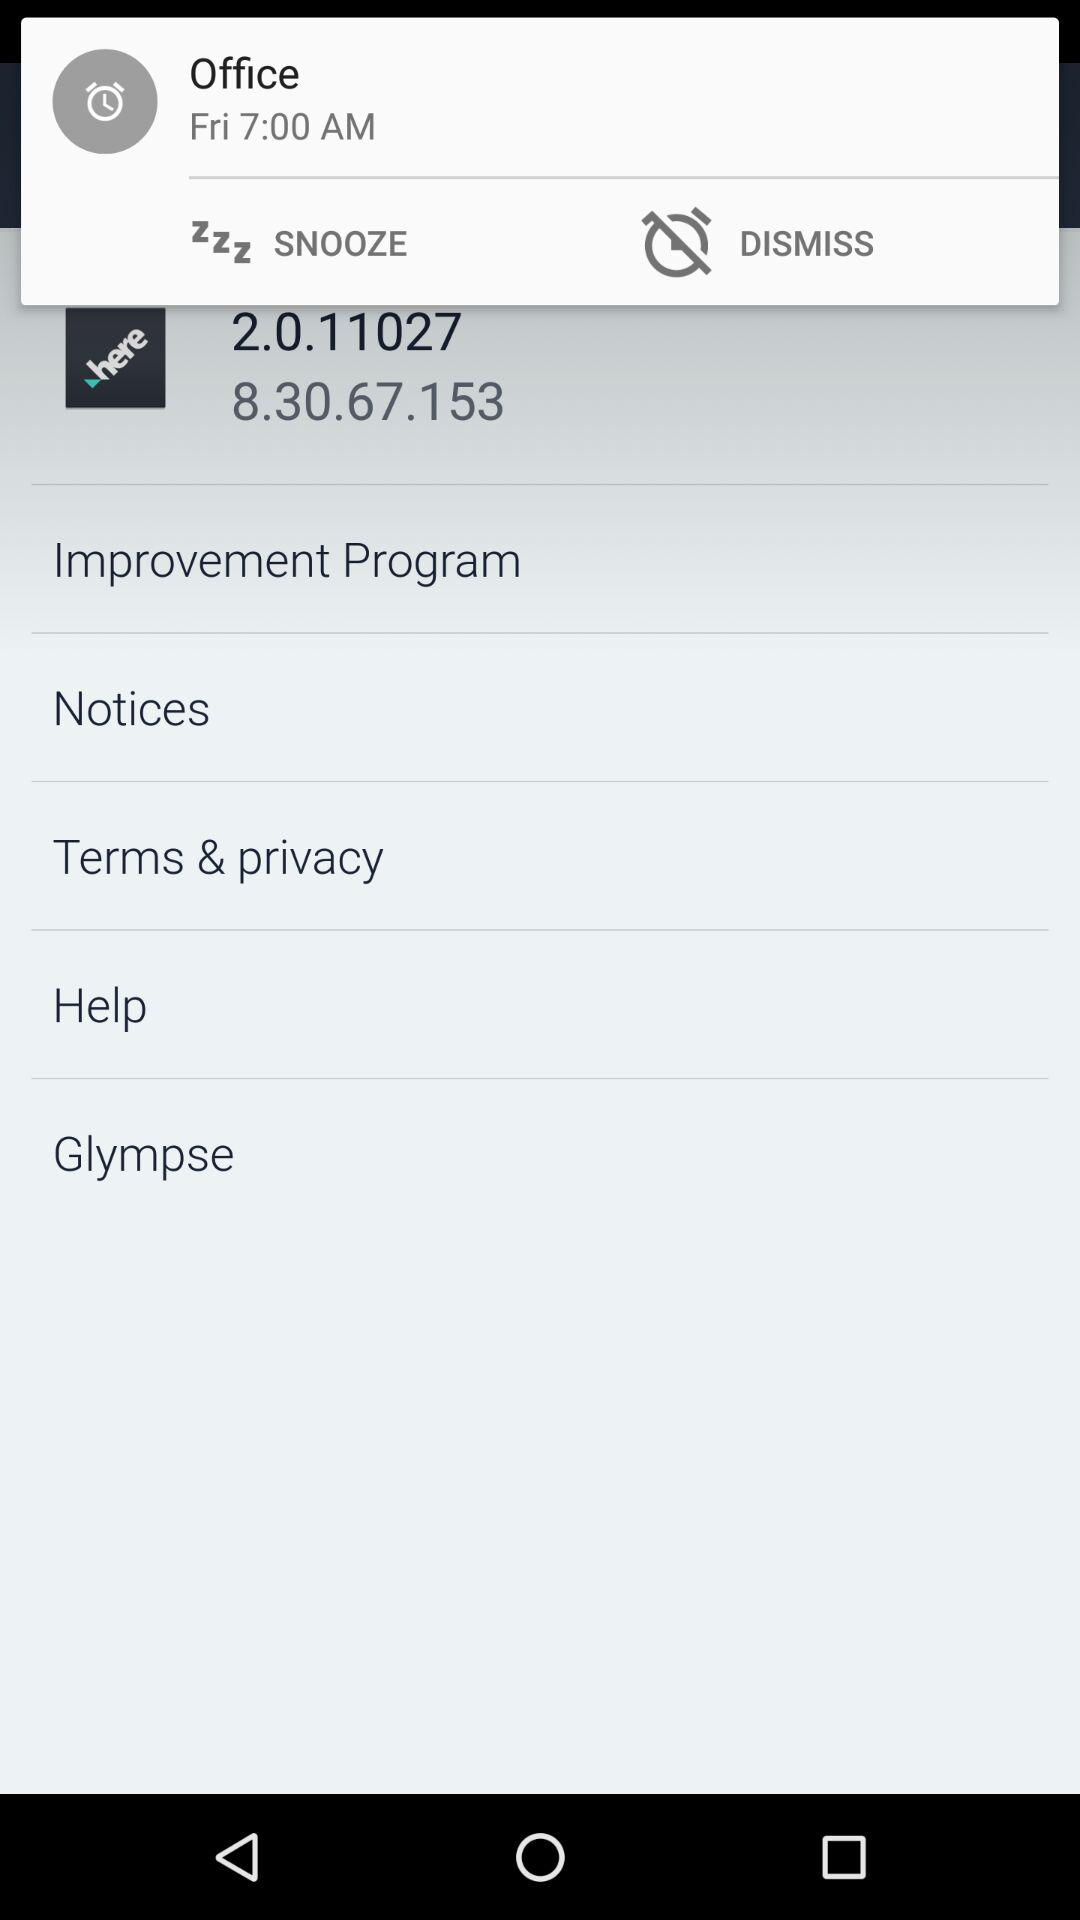What is the alarm time set for the office? The alarm time set for the office is 7:00 AM. 